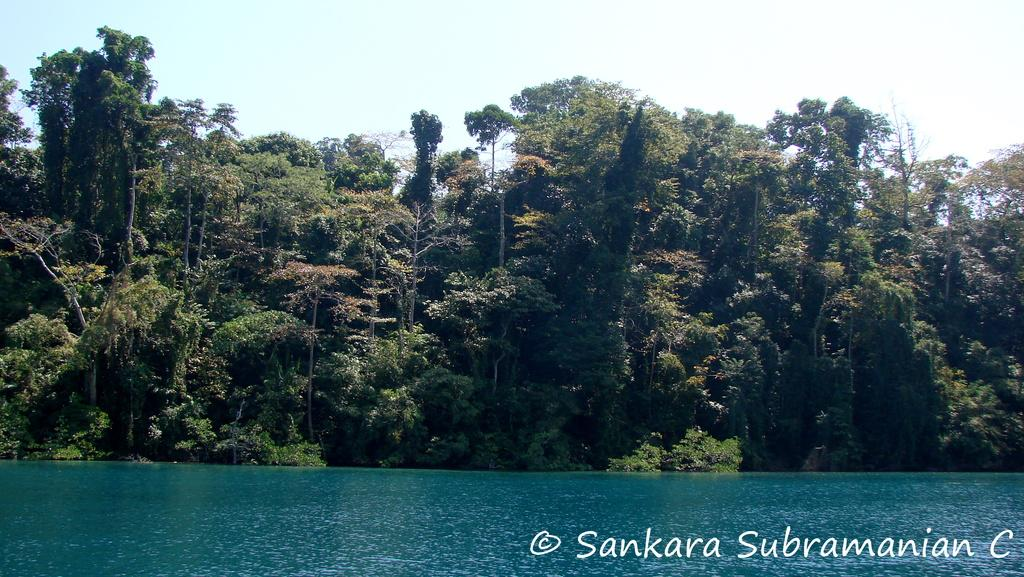What is the main subject in the center of the image? There is water in the center of the image. What can be seen in the background of the image? There are trees in the background of the image. Where is the text located in the image? The text is written on the bottom right of the image. What type of toys are scattered on the desk in the image? There is no desk or toys present in the image. What is the person's desire in the image? There is no person or indication of desire in the image. 